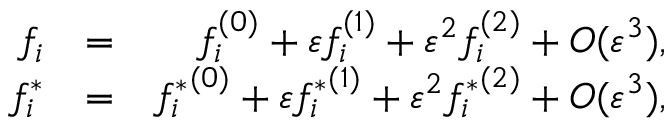Convert formula to latex. <formula><loc_0><loc_0><loc_500><loc_500>\begin{array} { r l r } { f _ { i } } & { = } & { f _ { i } ^ { ( 0 ) } + \varepsilon f _ { i } ^ { ( 1 ) } + \varepsilon ^ { 2 } f _ { i } ^ { ( 2 ) } + O ( \varepsilon ^ { 3 } ) , } \\ { { f _ { i } ^ { * } } } & { = } & { { f _ { i } ^ { * } } ^ { ( 0 ) } + \varepsilon { f _ { i } ^ { * } } ^ { ( 1 ) } + \varepsilon ^ { 2 } { f _ { i } ^ { * } } ^ { ( 2 ) } + O ( \varepsilon ^ { 3 } ) , } \end{array}</formula> 